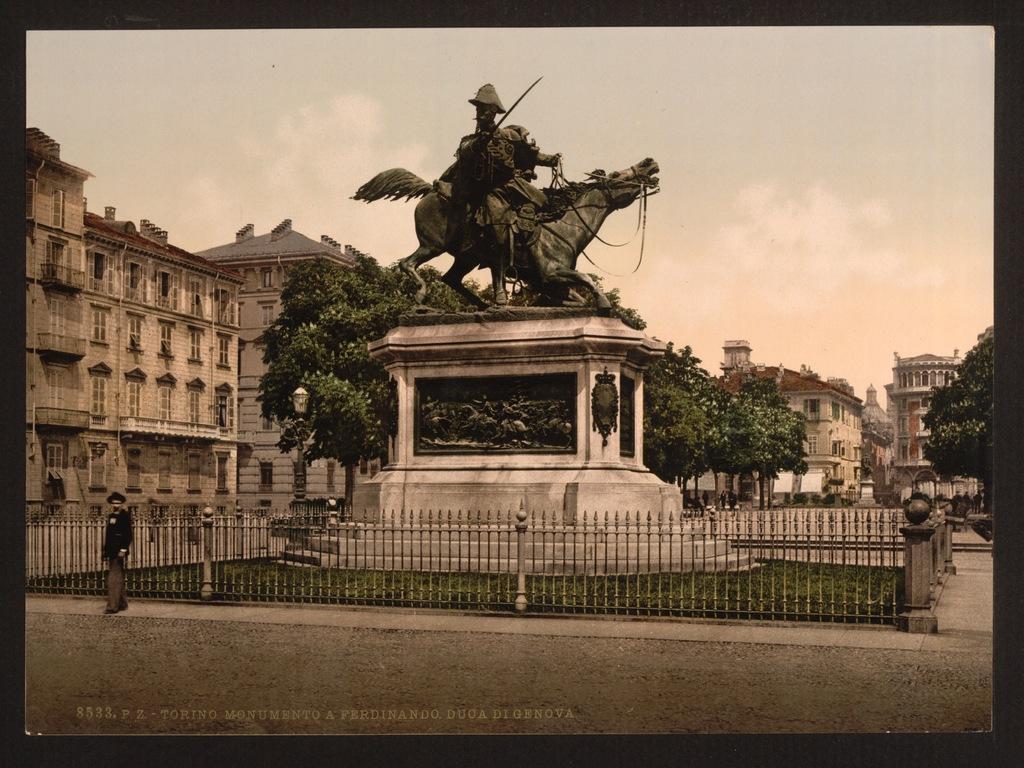Please provide a concise description of this image. In this picture we can see a man standing on the ground, statue, trees, buildings with windows and in the background we can see the sky with clouds. 